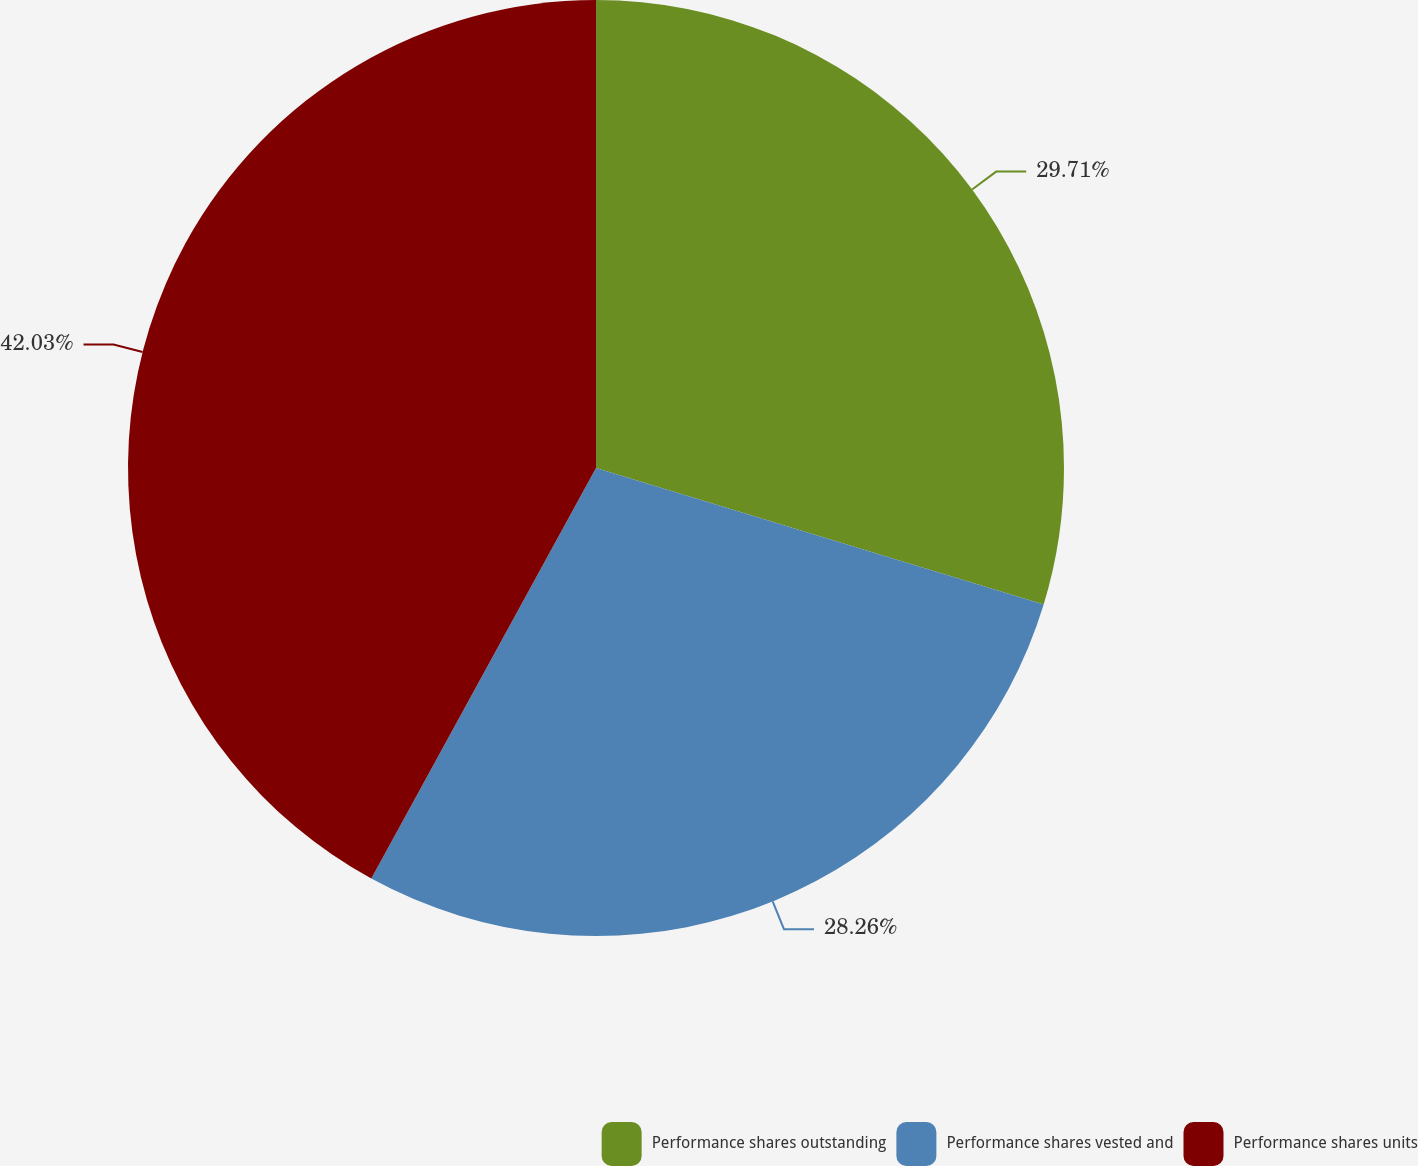Convert chart. <chart><loc_0><loc_0><loc_500><loc_500><pie_chart><fcel>Performance shares outstanding<fcel>Performance shares vested and<fcel>Performance shares units<nl><fcel>29.71%<fcel>28.26%<fcel>42.03%<nl></chart> 